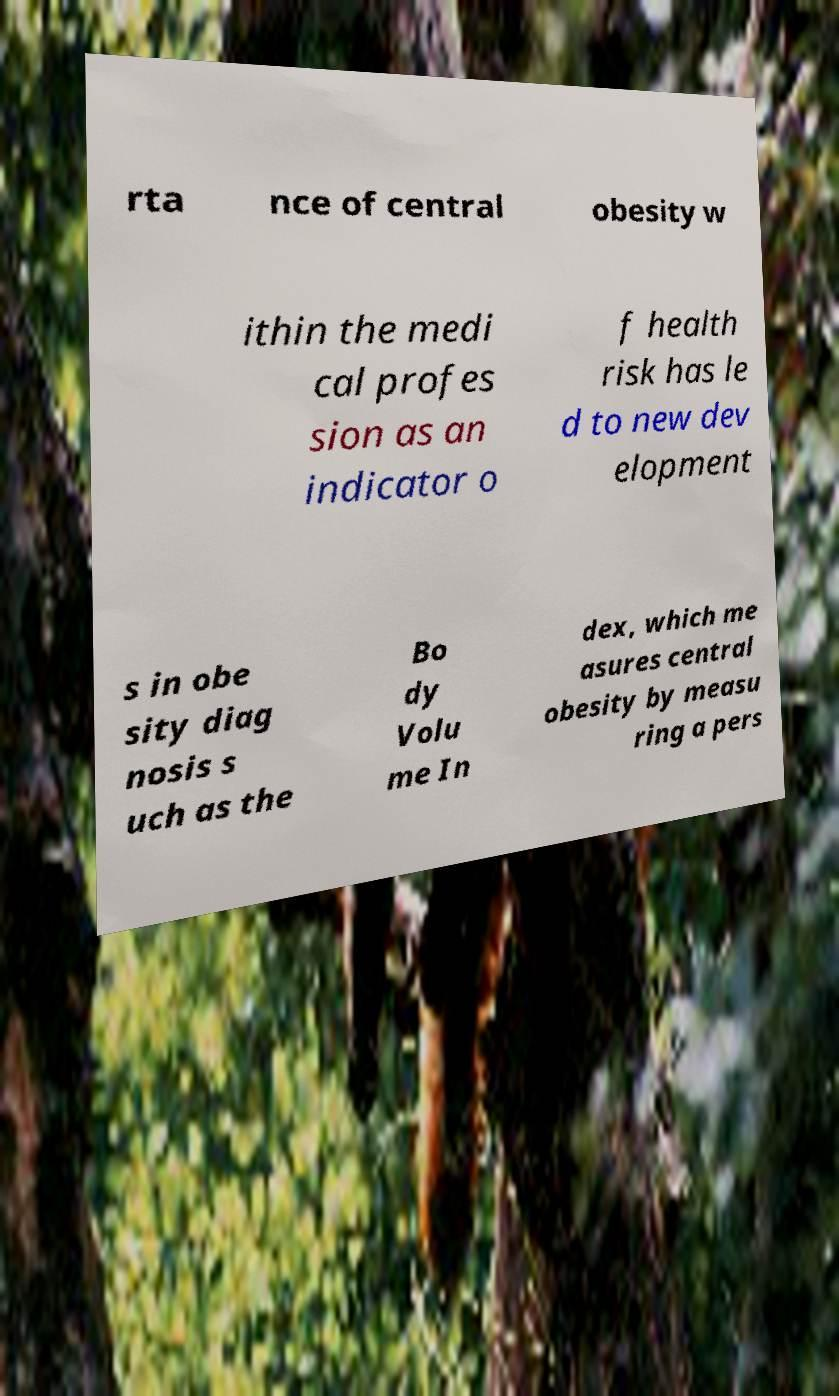Could you extract and type out the text from this image? rta nce of central obesity w ithin the medi cal profes sion as an indicator o f health risk has le d to new dev elopment s in obe sity diag nosis s uch as the Bo dy Volu me In dex, which me asures central obesity by measu ring a pers 